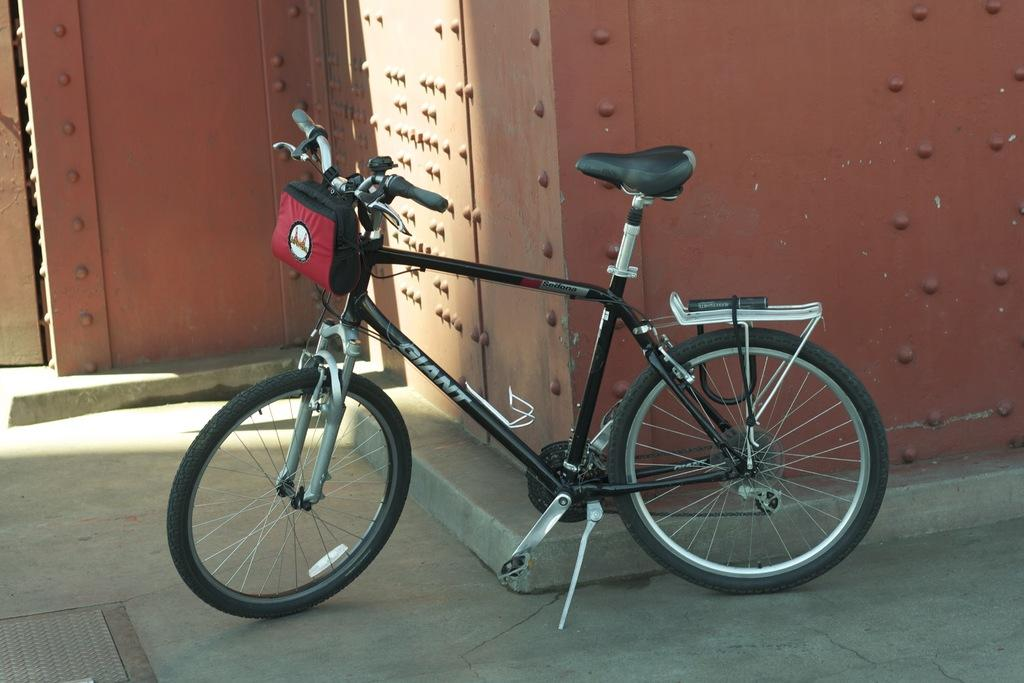What object is placed on the floor in the image? There is a bicycle on the floor in the image. What can be seen in the background of the image? There are walls visible in the background of the image. What type of gold object is visible on the bicycle in the image? There is no gold object present on the bicycle in the image. 